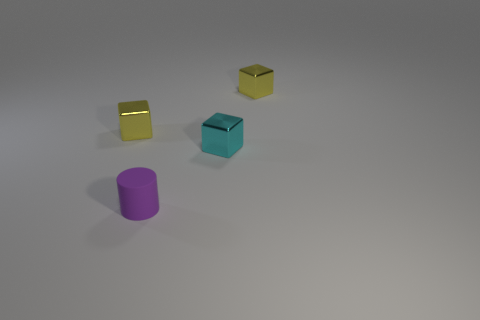Please describe the relative sizes of the objects. In the image, we see a variety of objects that differ in size. The cylinder appears to be the smallest in height, while the cubes are larger with the gold one being slightly smaller than the teal cube. 